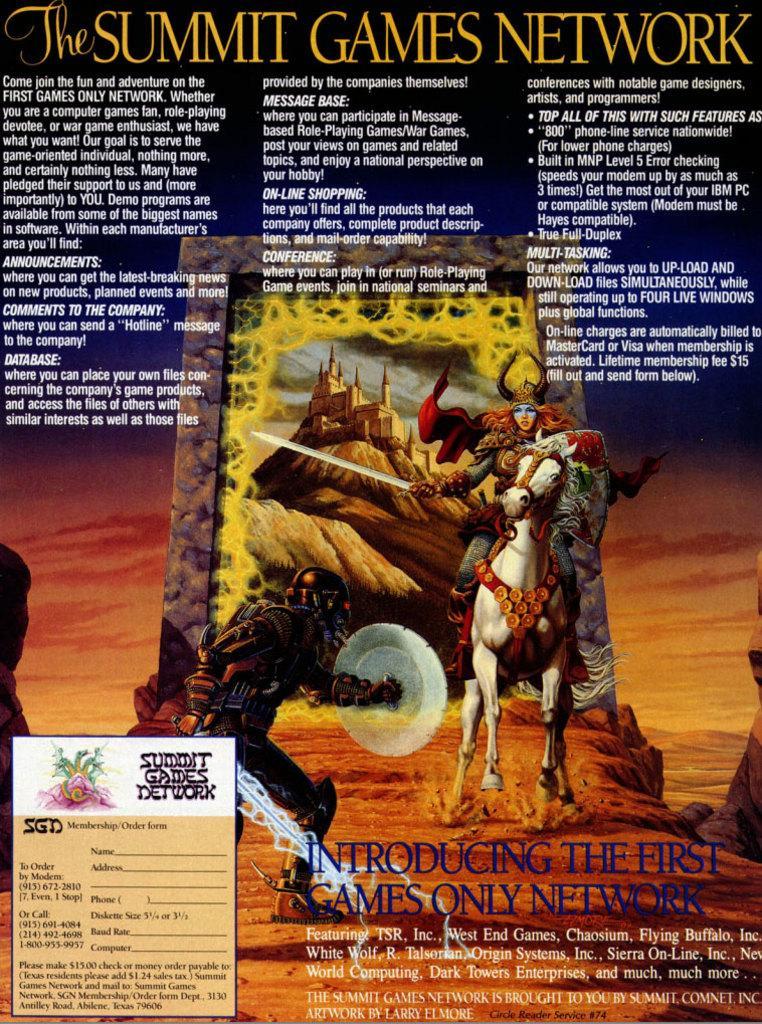How would you summarize this image in a sentence or two? It is a graphical image, in this a person is riding the horse. In the middle other person is fighting on the land. 